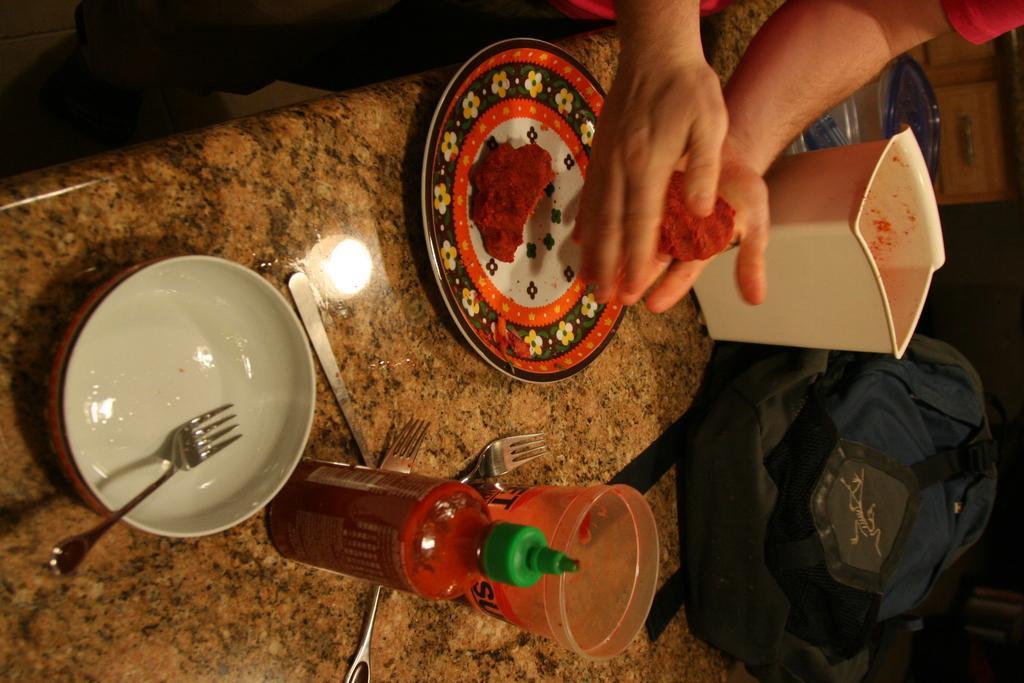How would you summarize this image in a sentence or two? In this picture, we see a table on which bowl, forks, sauce bottle, glass, plate containing eatables, a white plastic box and bag are placed. At the top of the picture, we see a man in red T-shirt is holding eatable in his hands. 